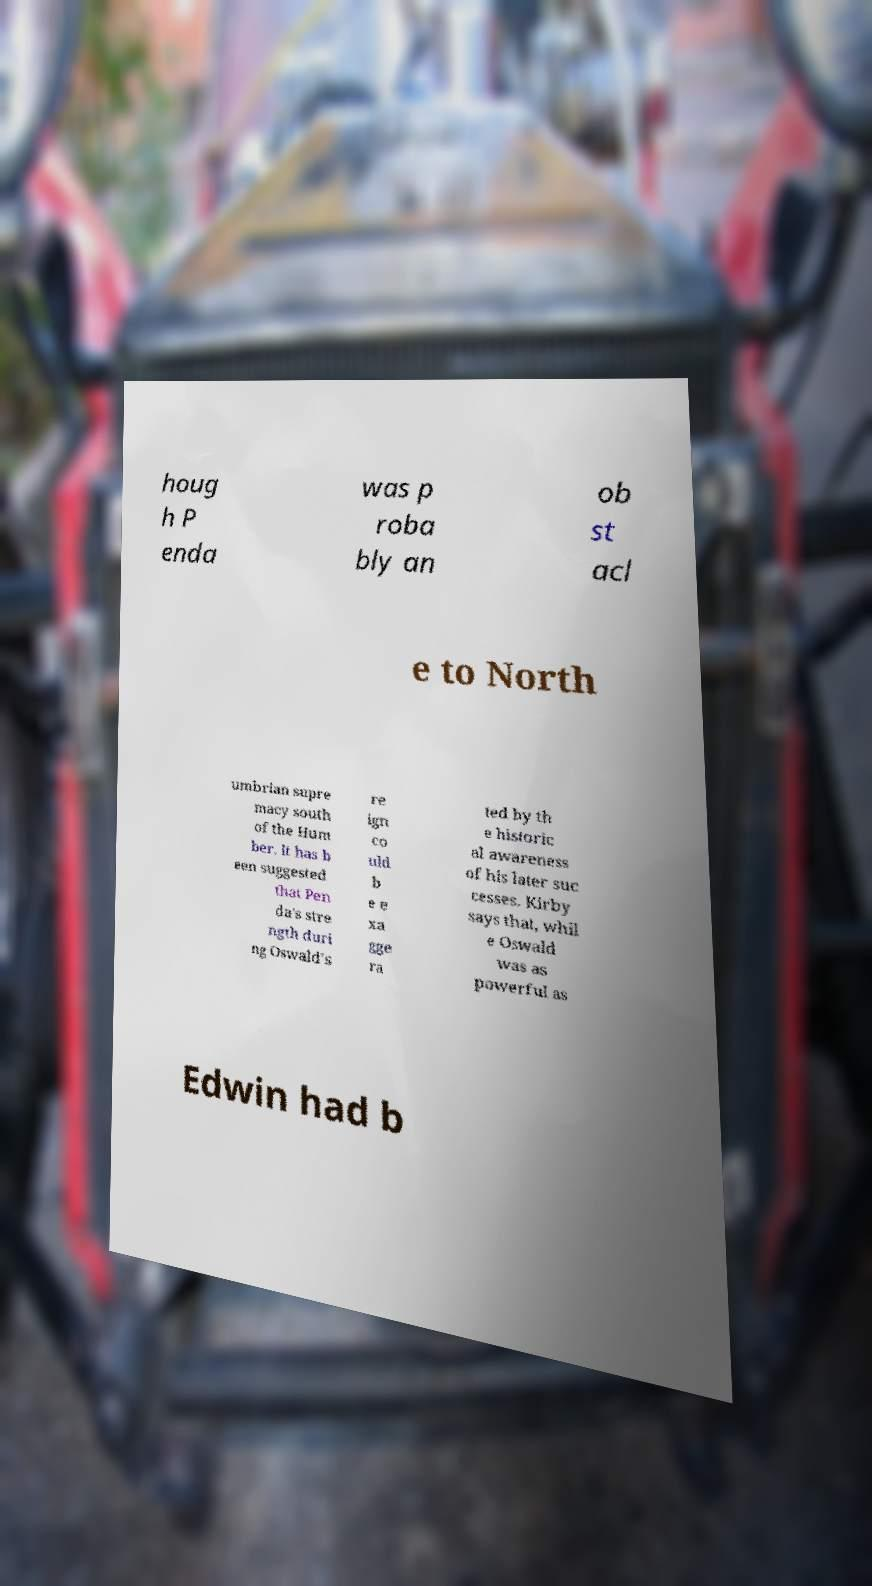What messages or text are displayed in this image? I need them in a readable, typed format. houg h P enda was p roba bly an ob st acl e to North umbrian supre macy south of the Hum ber. It has b een suggested that Pen da's stre ngth duri ng Oswald's re ign co uld b e e xa gge ra ted by th e historic al awareness of his later suc cesses. Kirby says that, whil e Oswald was as powerful as Edwin had b 